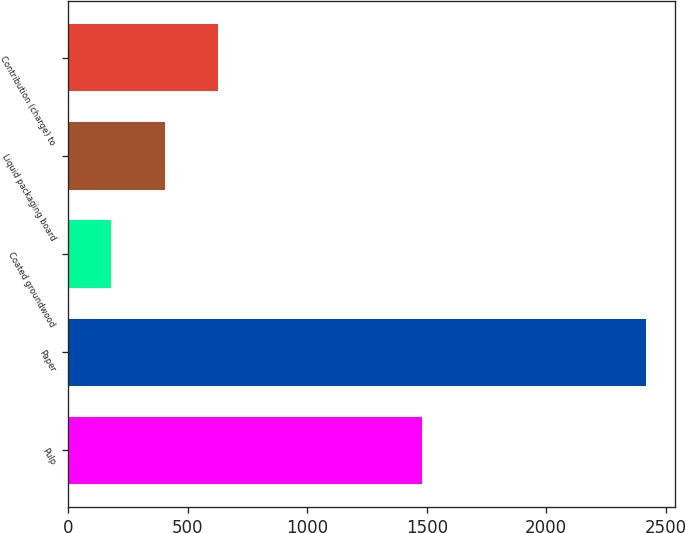Convert chart. <chart><loc_0><loc_0><loc_500><loc_500><bar_chart><fcel>Pulp<fcel>Paper<fcel>Coated groundwood<fcel>Liquid packaging board<fcel>Contribution (charge) to<nl><fcel>1482<fcel>2417<fcel>180<fcel>403.7<fcel>627.4<nl></chart> 